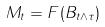Convert formula to latex. <formula><loc_0><loc_0><loc_500><loc_500>M _ { t } = F ( B _ { t \wedge \tau } )</formula> 